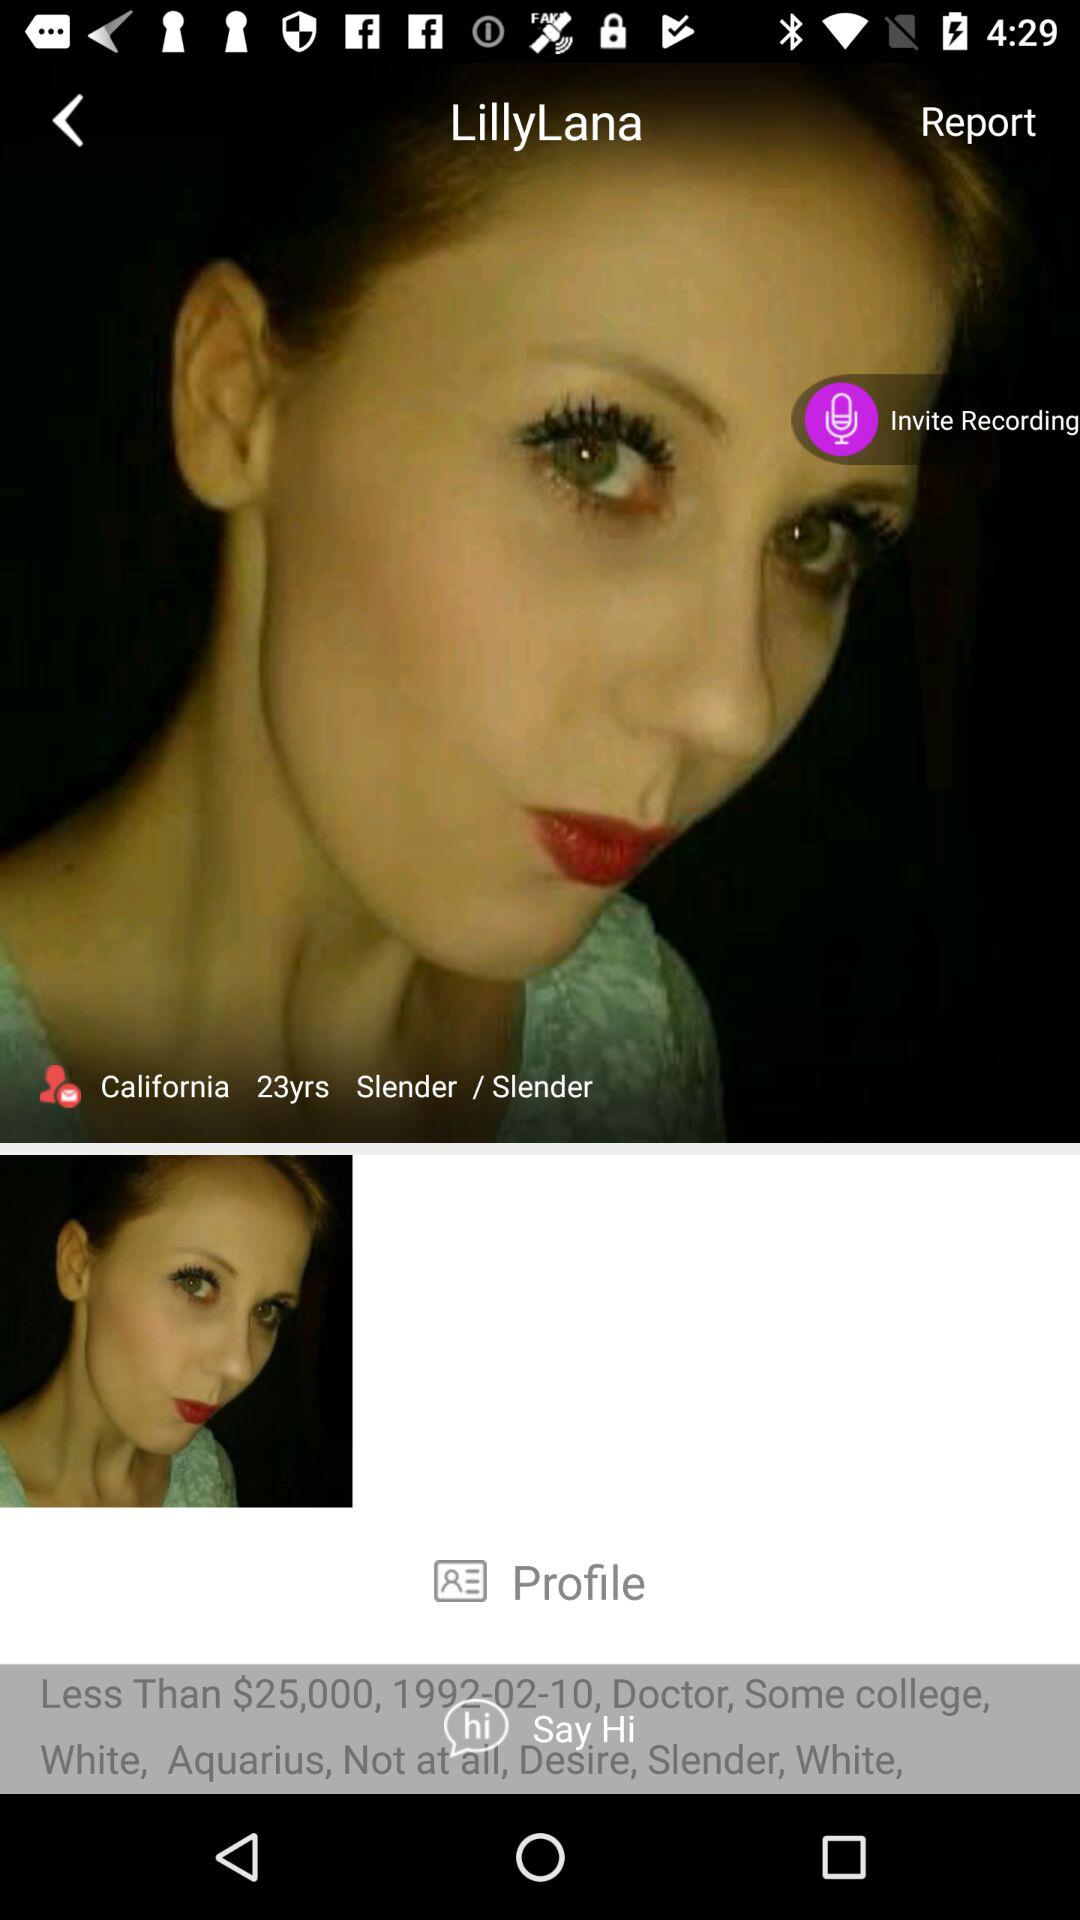What's the age of the user? The age of the user is 23 years. 